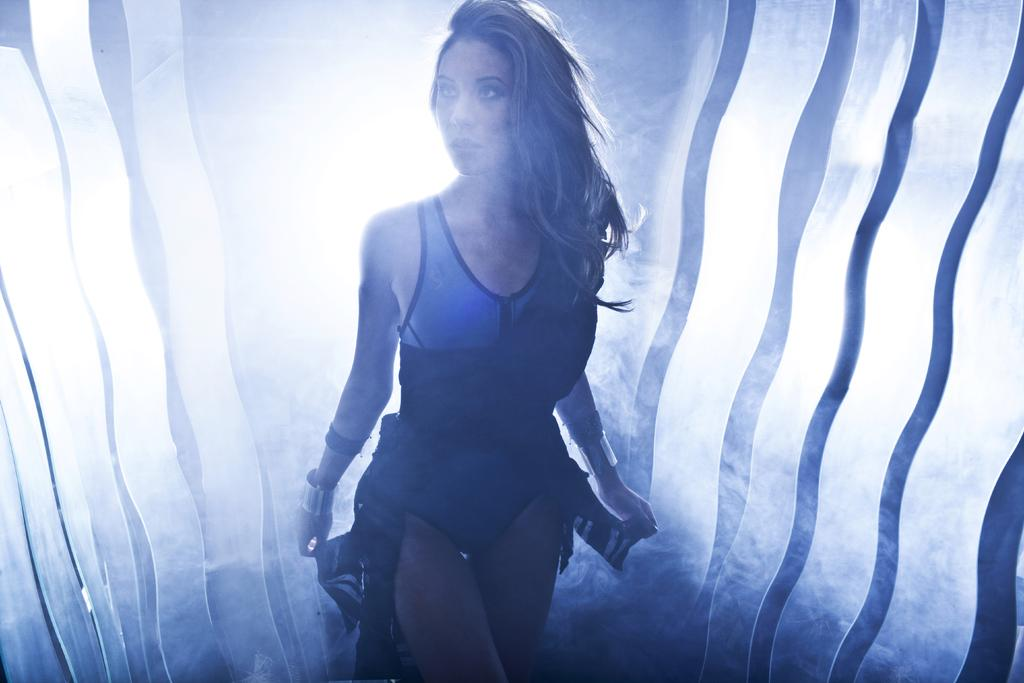Who is present in the image? There is a woman in the image. What else can be seen in the image besides the woman? There is smoke in the image. How many fingers does the woman have in the image? The number of fingers the woman has cannot be determined from the image, as her hands are not visible. 